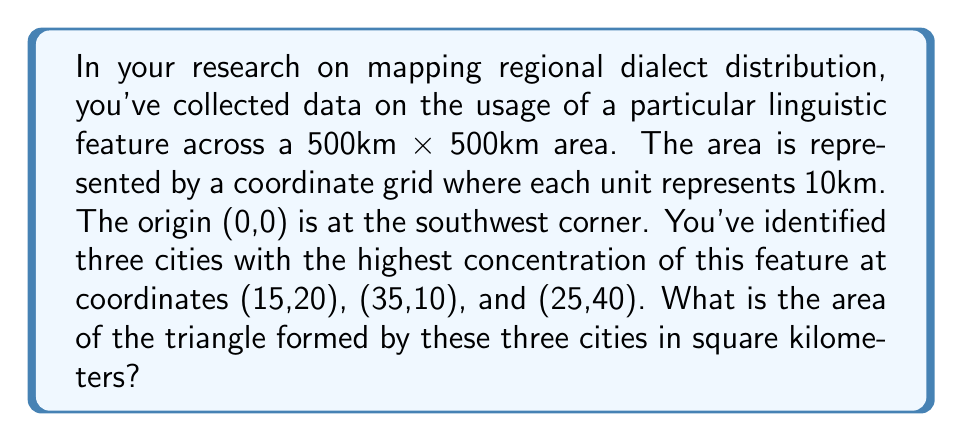Provide a solution to this math problem. To solve this problem, we'll follow these steps:

1. Identify the coordinates of the three points:
   A(15,20), B(35,10), C(25,40)

2. Use the formula for the area of a triangle given three points:
   $$Area = \frac{1}{2}|x_1(y_2 - y_3) + x_2(y_3 - y_1) + x_3(y_1 - y_2)|$$

3. Substitute the values:
   $$Area = \frac{1}{2}|15(10 - 40) + 35(40 - 20) + 25(20 - 10)|$$

4. Simplify:
   $$Area = \frac{1}{2}|15(-30) + 35(20) + 25(10)|$$
   $$Area = \frac{1}{2}|-450 + 700 + 250|$$
   $$Area = \frac{1}{2}|500|$$
   $$Area = 250$$

5. Remember that each unit represents 10km, so we need to multiply our result by $10^2 = 100$:
   $$Actual Area = 250 * 100 = 25,000 \text{ sq km}$$

[asy]
import geometry;

unitsize(5mm);
draw((0,0)--(50,0)--(50,50)--(0,50)--cycle);
dot((15,20));
dot((35,10));
dot((25,40));
draw((15,20)--(35,10)--(25,40)--cycle, red);
label("A(15,20)", (15,20), NE);
label("B(35,10)", (35,10), SE);
label("C(25,40)", (25,40), N);
label("0", (0,0), SW);
label("500km", (50,0), SE);
label("500km", (0,50), NW);
[/asy]
Answer: 25,000 square kilometers 